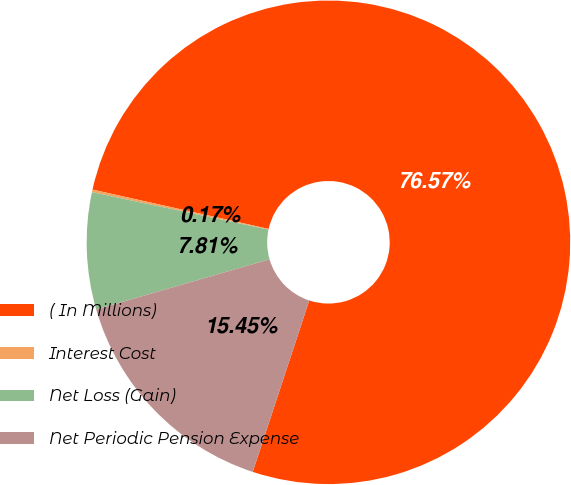Convert chart. <chart><loc_0><loc_0><loc_500><loc_500><pie_chart><fcel>( In Millions)<fcel>Interest Cost<fcel>Net Loss (Gain)<fcel>Net Periodic Pension Expense<nl><fcel>76.58%<fcel>0.17%<fcel>7.81%<fcel>15.45%<nl></chart> 